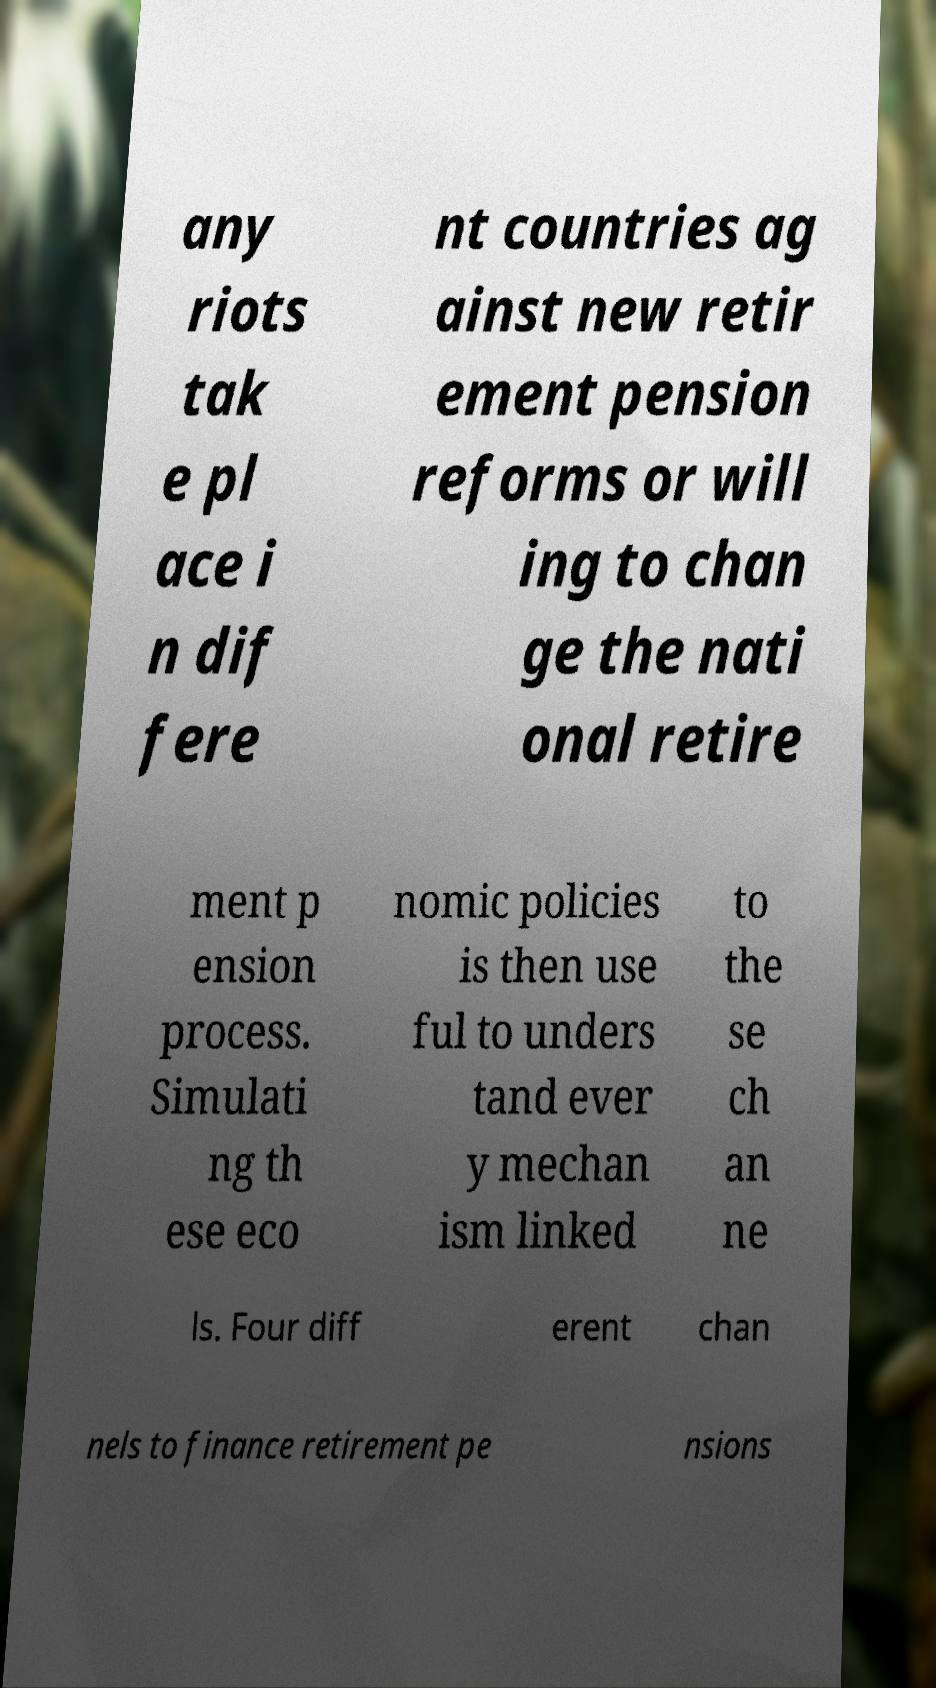Could you extract and type out the text from this image? any riots tak e pl ace i n dif fere nt countries ag ainst new retir ement pension reforms or will ing to chan ge the nati onal retire ment p ension process. Simulati ng th ese eco nomic policies is then use ful to unders tand ever y mechan ism linked to the se ch an ne ls. Four diff erent chan nels to finance retirement pe nsions 